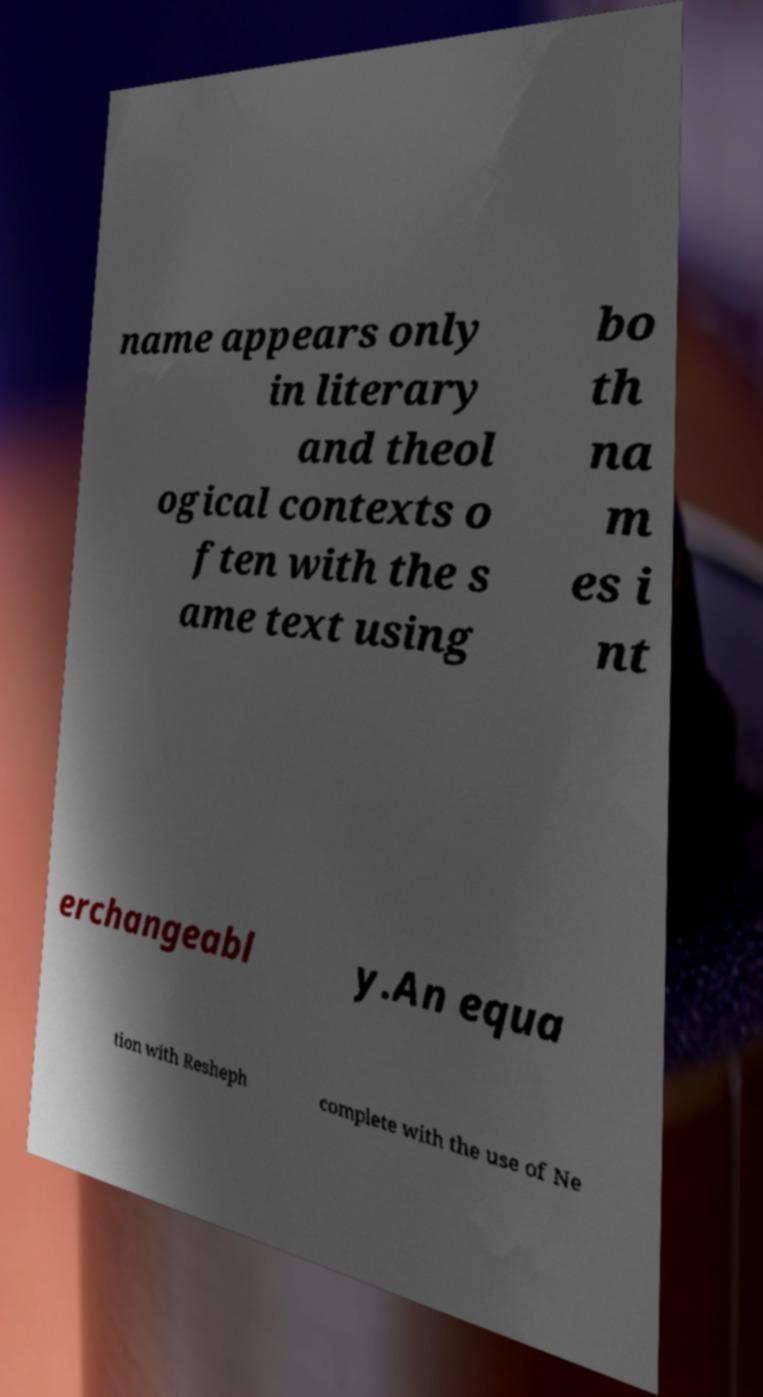Can you read and provide the text displayed in the image?This photo seems to have some interesting text. Can you extract and type it out for me? name appears only in literary and theol ogical contexts o ften with the s ame text using bo th na m es i nt erchangeabl y.An equa tion with Resheph complete with the use of Ne 